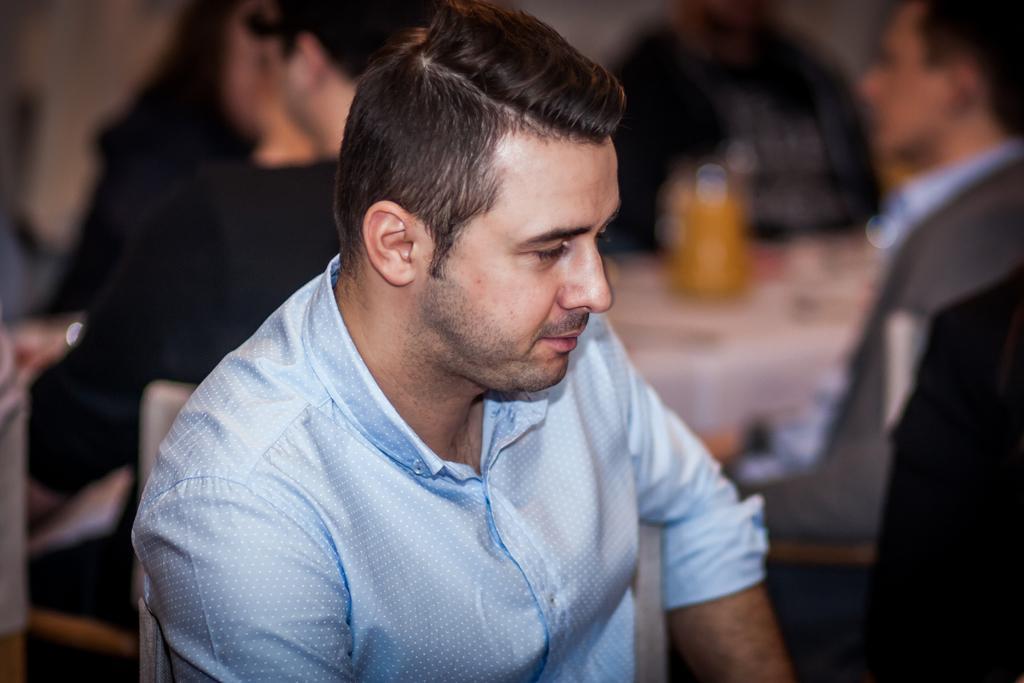In one or two sentences, can you explain what this image depicts? In the center of the image, we can see a man sitting on the chair and in the background, there are some other people sitting and we can see a table. 